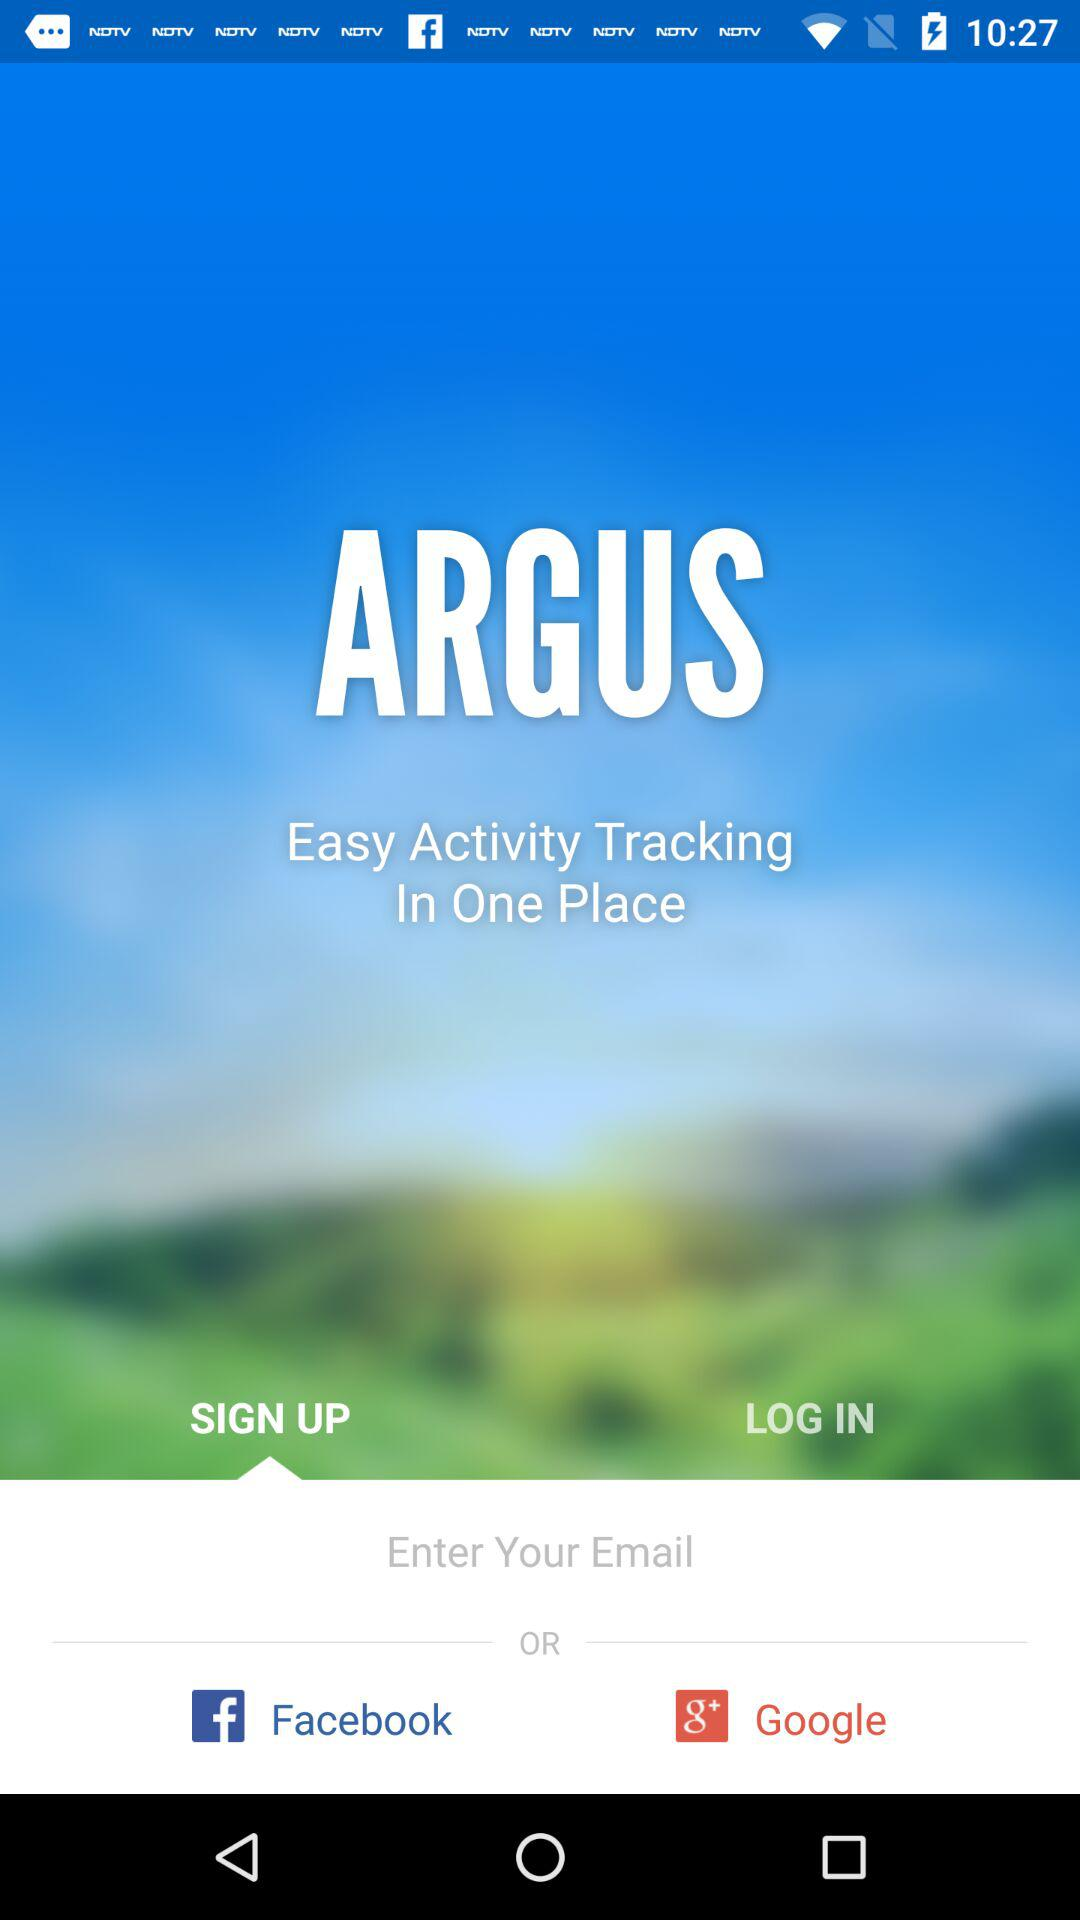Which are the different login options? The different login options are "Email", "Facebook" and "Google+". 